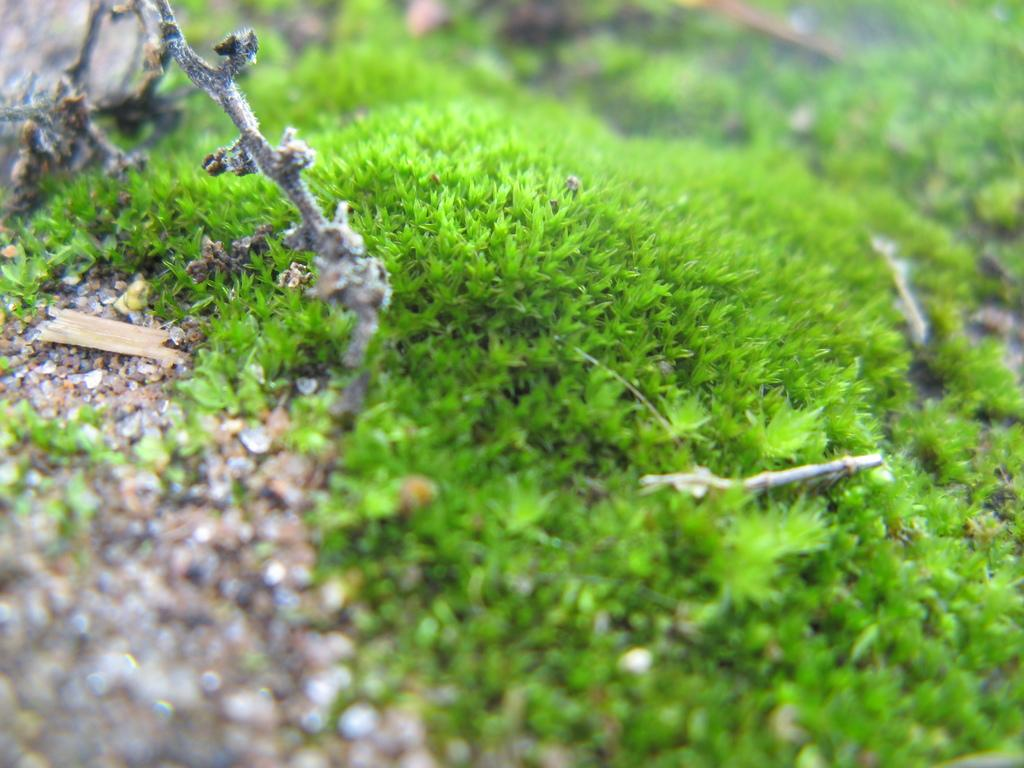What type of vegetation is present in the image? There is grass in the image. Can you describe any other objects or features in the image? There appears to be a rock in the top right corner of the image. How would you describe the background of the image? The background of the image is blurry. How does the stranger interact with the crate in the image? There is no stranger or crate present in the image. 